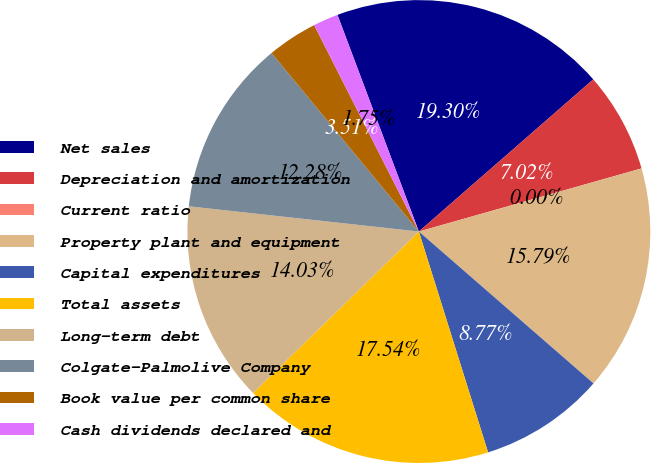<chart> <loc_0><loc_0><loc_500><loc_500><pie_chart><fcel>Net sales<fcel>Depreciation and amortization<fcel>Current ratio<fcel>Property plant and equipment<fcel>Capital expenditures<fcel>Total assets<fcel>Long-term debt<fcel>Colgate-Palmolive Company<fcel>Book value per common share<fcel>Cash dividends declared and<nl><fcel>19.3%<fcel>7.02%<fcel>0.0%<fcel>15.79%<fcel>8.77%<fcel>17.54%<fcel>14.03%<fcel>12.28%<fcel>3.51%<fcel>1.75%<nl></chart> 